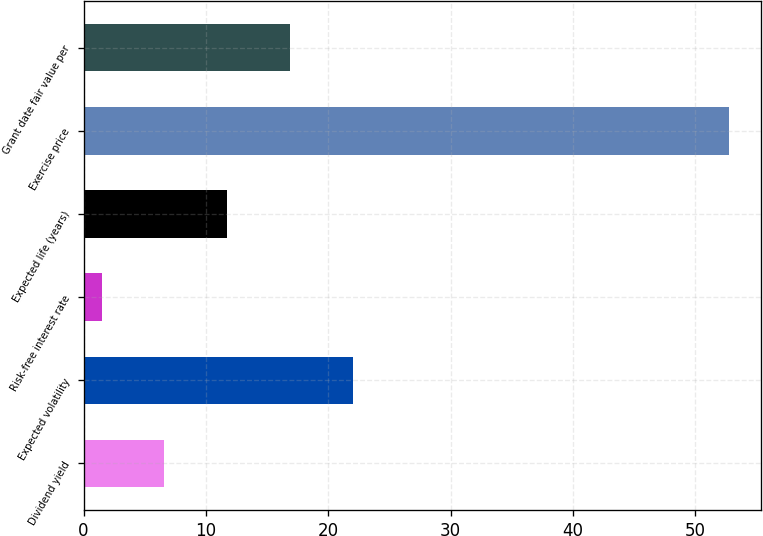Convert chart to OTSL. <chart><loc_0><loc_0><loc_500><loc_500><bar_chart><fcel>Dividend yield<fcel>Expected volatility<fcel>Risk-free interest rate<fcel>Expected life (years)<fcel>Exercise price<fcel>Grant date fair value per<nl><fcel>6.61<fcel>22<fcel>1.48<fcel>11.74<fcel>52.75<fcel>16.87<nl></chart> 